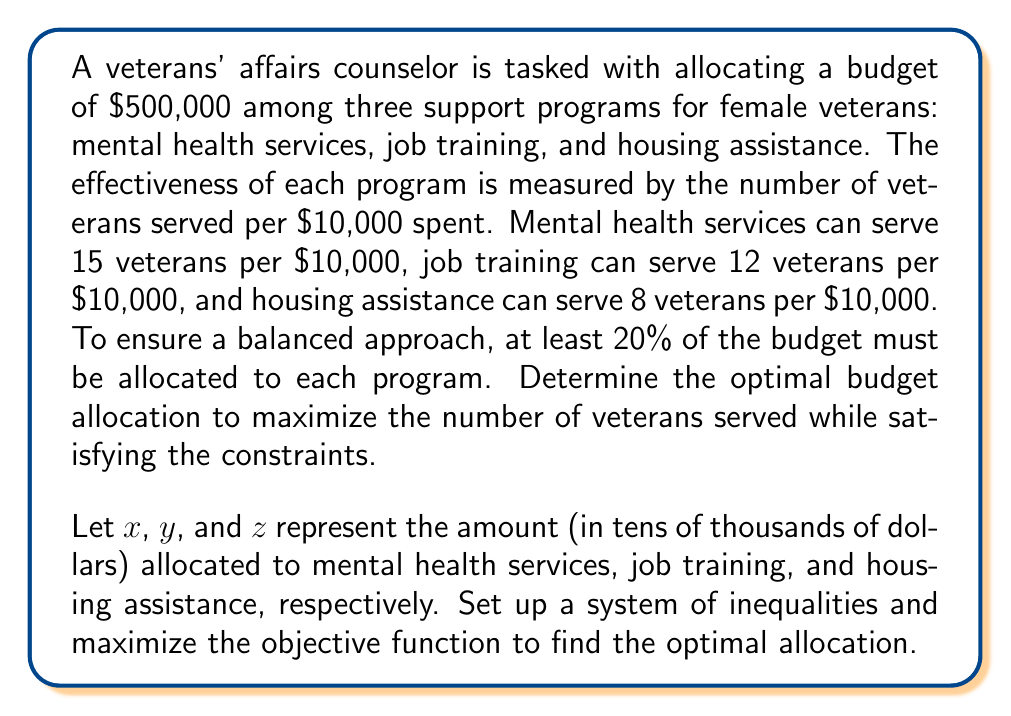Help me with this question. Step 1: Set up the objective function to maximize the number of veterans served.
$$\text{Maximize: } f(x,y,z) = 15x + 12y + 8z$$

Step 2: Set up the constraints.
Total budget constraint: $$x + y + z = 50$$ (since the budget is $500,000)
Minimum allocation constraints:
$$x \geq 10, y \geq 10, z \geq 10$$ (20% of $500,000 is $100,000 or 10 units of $10,000)

Step 3: Solve the linear programming problem.
We can use the simplex method or a graphical approach. In this case, we'll use logical reasoning:

a) The most efficient program is mental health services (15 veterans/$10,000), so we should allocate as much as possible to this program.
b) The second most efficient is job training (12 veterans/$10,000), so we should allocate the remaining budget to this program after meeting the minimum requirements for housing assistance.

Step 4: Calculate the optimal allocation.
- Allocate the minimum to housing assistance: $z = 10$ ($100,000)
- Allocate the minimum to job training: $y = 10$ ($100,000)
- Allocate the remaining to mental health services: $x = 50 - 10 - 10 = 30$ ($300,000)

Step 5: Verify the solution satisfies all constraints.
- Total budget: $30 + 10 + 10 = 50$ (✓)
- Minimum allocations: $30 \geq 10$, $10 \geq 10$, $10 \geq 10$ (✓)

Step 6: Calculate the total number of veterans served.
$$15(30) + 12(10) + 8(10) = 450 + 120 + 80 = 650$$
Answer: Mental health services: $300,000; Job training: $100,000; Housing assistance: $100,000; Total veterans served: 650 